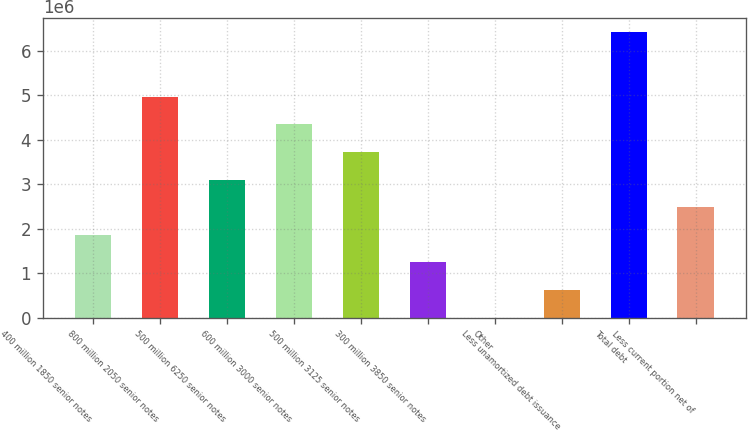<chart> <loc_0><loc_0><loc_500><loc_500><bar_chart><fcel>400 million 1850 senior notes<fcel>800 million 2050 senior notes<fcel>500 million 6250 senior notes<fcel>600 million 3000 senior notes<fcel>500 million 3125 senior notes<fcel>300 million 3850 senior notes<fcel>Other<fcel>Less unamortized debt issuance<fcel>Total debt<fcel>Less current portion net of<nl><fcel>1.86495e+06<fcel>4.96823e+06<fcel>3.10626e+06<fcel>4.34757e+06<fcel>3.72692e+06<fcel>1.2443e+06<fcel>2989<fcel>623644<fcel>6.42922e+06<fcel>2.48561e+06<nl></chart> 